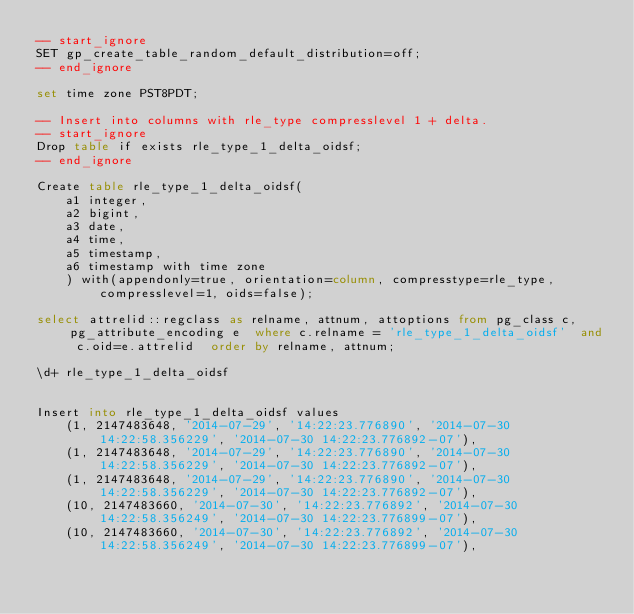<code> <loc_0><loc_0><loc_500><loc_500><_SQL_>-- start_ignore
SET gp_create_table_random_default_distribution=off;
-- end_ignore

set time zone PST8PDT;

-- Insert into columns with rle_type compresslevel 1 + delta.
-- start_ignore
Drop table if exists rle_type_1_delta_oidsf;
-- end_ignore

Create table rle_type_1_delta_oidsf(
    a1 integer,
    a2 bigint,
    a3 date,
    a4 time,
    a5 timestamp,
    a6 timestamp with time zone
    ) with(appendonly=true, orientation=column, compresstype=rle_type, compresslevel=1, oids=false);

select attrelid::regclass as relname, attnum, attoptions from pg_class c, pg_attribute_encoding e  where c.relname = 'rle_type_1_delta_oidsf'  and c.oid=e.attrelid  order by relname, attnum;

\d+ rle_type_1_delta_oidsf


Insert into rle_type_1_delta_oidsf values
    (1, 2147483648, '2014-07-29', '14:22:23.776890', '2014-07-30 14:22:58.356229', '2014-07-30 14:22:23.776892-07'),
    (1, 2147483648, '2014-07-29', '14:22:23.776890', '2014-07-30 14:22:58.356229', '2014-07-30 14:22:23.776892-07'),
    (1, 2147483648, '2014-07-29', '14:22:23.776890', '2014-07-30 14:22:58.356229', '2014-07-30 14:22:23.776892-07'),
    (10, 2147483660, '2014-07-30', '14:22:23.776892', '2014-07-30 14:22:58.356249', '2014-07-30 14:22:23.776899-07'),
    (10, 2147483660, '2014-07-30', '14:22:23.776892', '2014-07-30 14:22:58.356249', '2014-07-30 14:22:23.776899-07'),</code> 